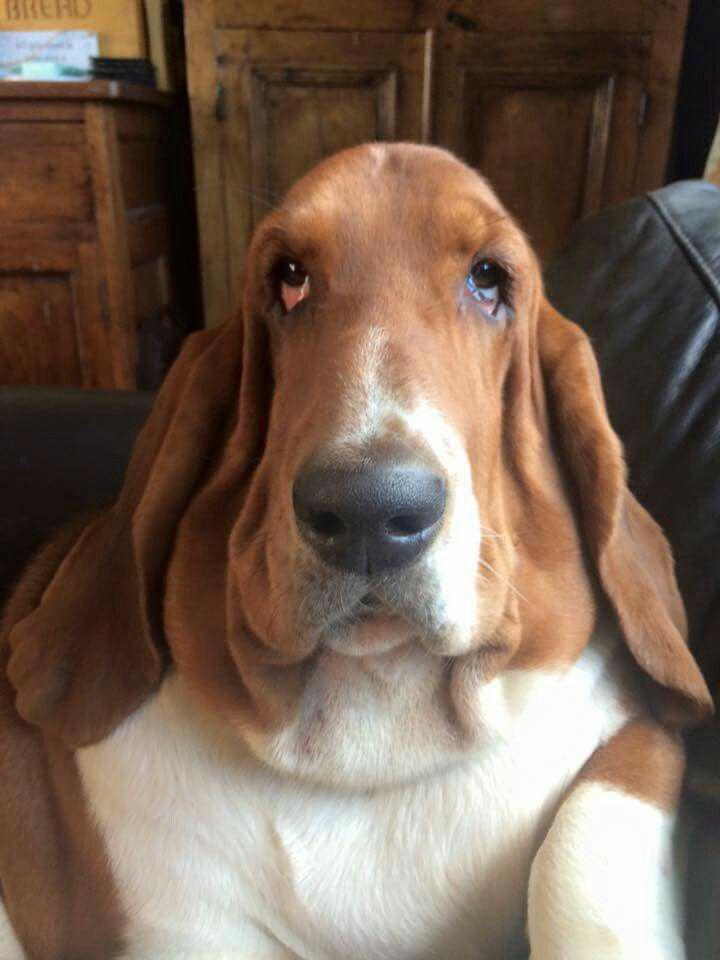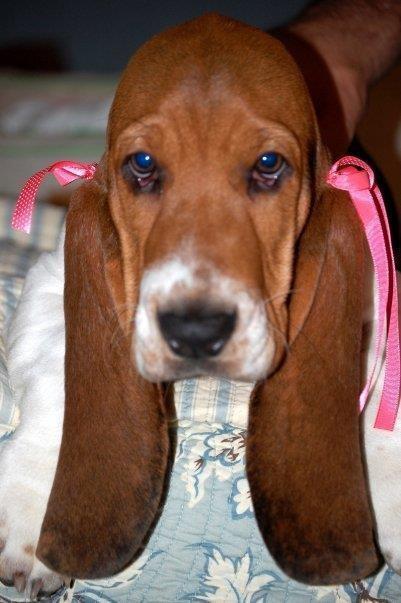The first image is the image on the left, the second image is the image on the right. Evaluate the accuracy of this statement regarding the images: "on the left picture the dog has their head laying down". Is it true? Answer yes or no. No. 